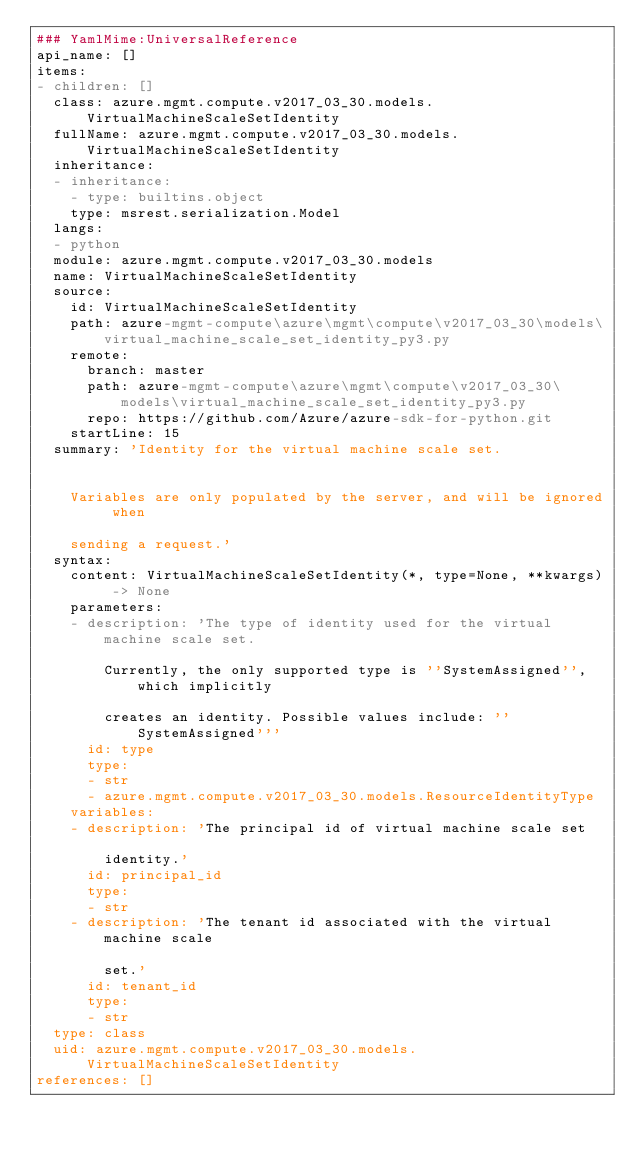Convert code to text. <code><loc_0><loc_0><loc_500><loc_500><_YAML_>### YamlMime:UniversalReference
api_name: []
items:
- children: []
  class: azure.mgmt.compute.v2017_03_30.models.VirtualMachineScaleSetIdentity
  fullName: azure.mgmt.compute.v2017_03_30.models.VirtualMachineScaleSetIdentity
  inheritance:
  - inheritance:
    - type: builtins.object
    type: msrest.serialization.Model
  langs:
  - python
  module: azure.mgmt.compute.v2017_03_30.models
  name: VirtualMachineScaleSetIdentity
  source:
    id: VirtualMachineScaleSetIdentity
    path: azure-mgmt-compute\azure\mgmt\compute\v2017_03_30\models\virtual_machine_scale_set_identity_py3.py
    remote:
      branch: master
      path: azure-mgmt-compute\azure\mgmt\compute\v2017_03_30\models\virtual_machine_scale_set_identity_py3.py
      repo: https://github.com/Azure/azure-sdk-for-python.git
    startLine: 15
  summary: 'Identity for the virtual machine scale set.


    Variables are only populated by the server, and will be ignored when

    sending a request.'
  syntax:
    content: VirtualMachineScaleSetIdentity(*, type=None, **kwargs) -> None
    parameters:
    - description: 'The type of identity used for the virtual machine scale set.

        Currently, the only supported type is ''SystemAssigned'', which implicitly

        creates an identity. Possible values include: ''SystemAssigned'''
      id: type
      type:
      - str
      - azure.mgmt.compute.v2017_03_30.models.ResourceIdentityType
    variables:
    - description: 'The principal id of virtual machine scale set

        identity.'
      id: principal_id
      type:
      - str
    - description: 'The tenant id associated with the virtual machine scale

        set.'
      id: tenant_id
      type:
      - str
  type: class
  uid: azure.mgmt.compute.v2017_03_30.models.VirtualMachineScaleSetIdentity
references: []
</code> 